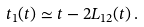<formula> <loc_0><loc_0><loc_500><loc_500>t _ { 1 } ( t ) \simeq t - 2 L _ { 1 2 } ( t ) \, .</formula> 